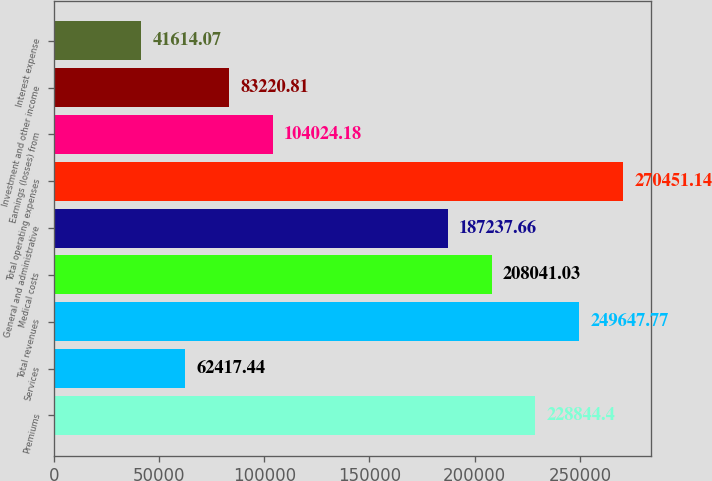<chart> <loc_0><loc_0><loc_500><loc_500><bar_chart><fcel>Premiums<fcel>Services<fcel>Total revenues<fcel>Medical costs<fcel>General and administrative<fcel>Total operating expenses<fcel>Earnings (losses) from<fcel>Investment and other income<fcel>Interest expense<nl><fcel>228844<fcel>62417.4<fcel>249648<fcel>208041<fcel>187238<fcel>270451<fcel>104024<fcel>83220.8<fcel>41614.1<nl></chart> 